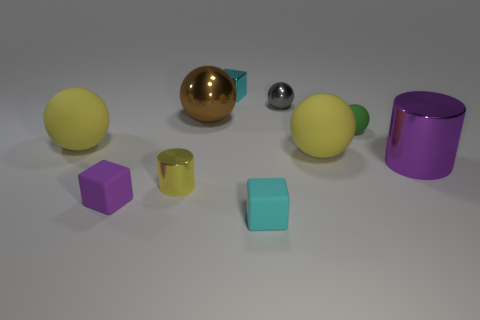There is a gray thing; are there any yellow things on the left side of it?
Provide a short and direct response. Yes. There is a small metallic thing in front of the big purple thing; does it have the same shape as the small cyan object that is in front of the tiny yellow cylinder?
Offer a very short reply. No. What number of things are large blue cylinders or large matte spheres right of the tiny shiny ball?
Make the answer very short. 1. What number of other things are the same shape as the cyan rubber object?
Provide a short and direct response. 2. Is the block behind the large brown shiny thing made of the same material as the big brown sphere?
Keep it short and to the point. Yes. How many objects are small yellow objects or small gray metallic objects?
Offer a terse response. 2. There is a brown object that is the same shape as the tiny green matte object; what size is it?
Give a very brief answer. Large. The metallic block is what size?
Provide a short and direct response. Small. Is the number of large yellow rubber spheres behind the green object greater than the number of tiny brown shiny things?
Make the answer very short. No. Is there any other thing that has the same material as the yellow cylinder?
Provide a short and direct response. Yes. 